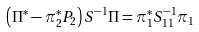<formula> <loc_0><loc_0><loc_500><loc_500>\left ( \Pi ^ { * } - \pi _ { 2 } ^ { * } P _ { 2 } \right ) S ^ { - 1 } \Pi = \pi _ { 1 } ^ { * } S _ { 1 1 } ^ { - 1 } \pi _ { 1 }</formula> 